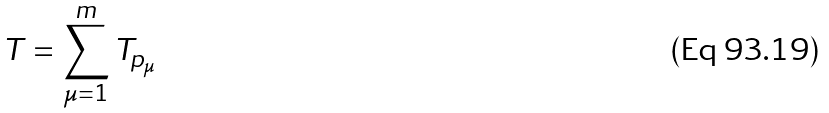Convert formula to latex. <formula><loc_0><loc_0><loc_500><loc_500>T = \sum ^ { m } _ { \mu = 1 } T _ { p _ { \mu } }</formula> 